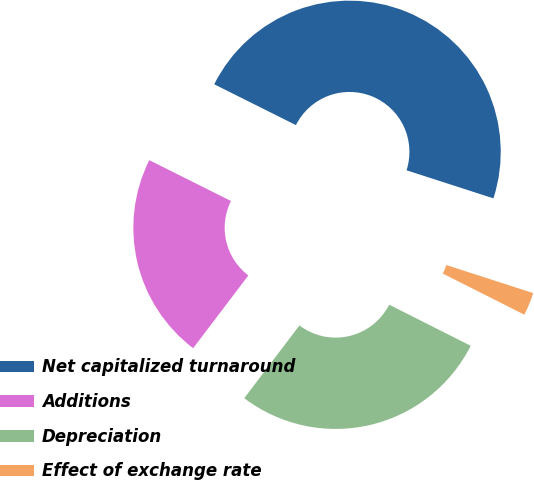Convert chart to OTSL. <chart><loc_0><loc_0><loc_500><loc_500><pie_chart><fcel>Net capitalized turnaround<fcel>Additions<fcel>Depreciation<fcel>Effect of exchange rate<nl><fcel>47.6%<fcel>22.04%<fcel>27.9%<fcel>2.46%<nl></chart> 